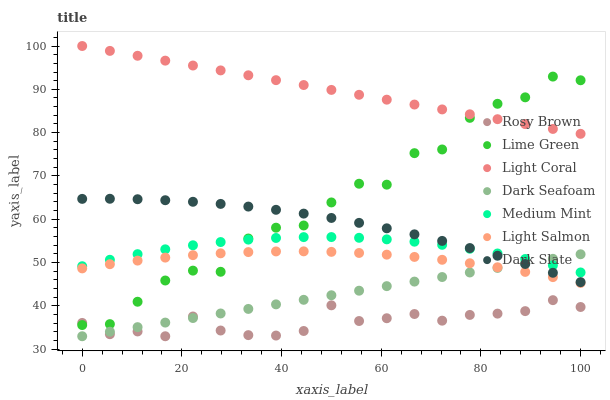Does Rosy Brown have the minimum area under the curve?
Answer yes or no. Yes. Does Light Coral have the maximum area under the curve?
Answer yes or no. Yes. Does Light Salmon have the minimum area under the curve?
Answer yes or no. No. Does Light Salmon have the maximum area under the curve?
Answer yes or no. No. Is Dark Seafoam the smoothest?
Answer yes or no. Yes. Is Lime Green the roughest?
Answer yes or no. Yes. Is Light Salmon the smoothest?
Answer yes or no. No. Is Light Salmon the roughest?
Answer yes or no. No. Does Rosy Brown have the lowest value?
Answer yes or no. Yes. Does Light Salmon have the lowest value?
Answer yes or no. No. Does Light Coral have the highest value?
Answer yes or no. Yes. Does Light Salmon have the highest value?
Answer yes or no. No. Is Rosy Brown less than Light Coral?
Answer yes or no. Yes. Is Medium Mint greater than Rosy Brown?
Answer yes or no. Yes. Does Light Salmon intersect Lime Green?
Answer yes or no. Yes. Is Light Salmon less than Lime Green?
Answer yes or no. No. Is Light Salmon greater than Lime Green?
Answer yes or no. No. Does Rosy Brown intersect Light Coral?
Answer yes or no. No. 